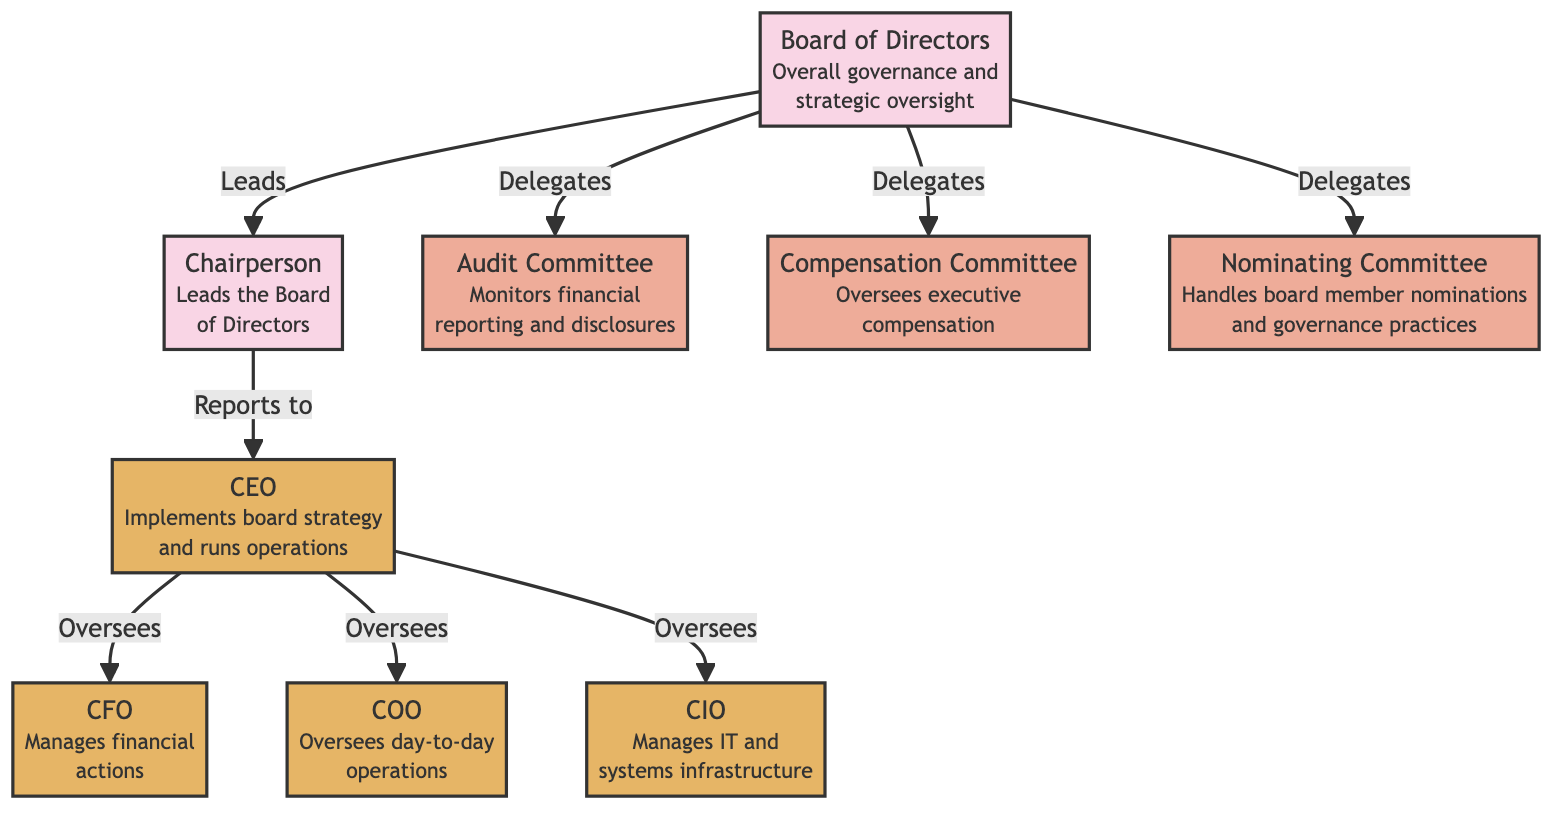What is the main role of the Board of Directors? The diagram states that the Board of Directors is responsible for "Overall governance and strategic oversight." This encapsulates their primary role within the organization.
Answer: Overall governance and strategic oversight How many committees are shown in the diagram? The diagram displays three committees: Audit Committee, Compensation Committee, and Nominating Committee. Counting these gives us the total number.
Answer: 3 Who is directly below the Chairperson? According to the diagram, the CEO reports directly to the Chairperson, establishing a chain of command.
Answer: CEO Which committee oversees executive compensation? The diagram indicates that the Compensation Committee is responsible for overseeing executive compensation. This is explicitly stated in its description.
Answer: Compensation Committee Which role implements board strategy? The diagram states that the CEO implements the board strategy, showing the direct connection between the board's decisions and operational execution.
Answer: CEO What is the function of the Audit Committee? The diagram specifies that the Audit Committee "Monitors financial reporting and disclosures," which defines its core function in the governance structure.
Answer: Monitors financial reporting and disclosures Which executive role manages financial actions? The diagram identifies the CFO as the role that manages financial actions, directly linking the executive function to financial oversight.
Answer: CFO How does the Board of Directors interact with the Nominating Committee? The diagram shows that the Board of Directors specifically delegates responsibilities to the Nominating Committee, indicating a formal interaction.
Answer: Delegates Who oversees the COO? The diagram clarifies that the CEO oversees the COO, illustrating a hierarchical relationship between these two roles.
Answer: CEO 